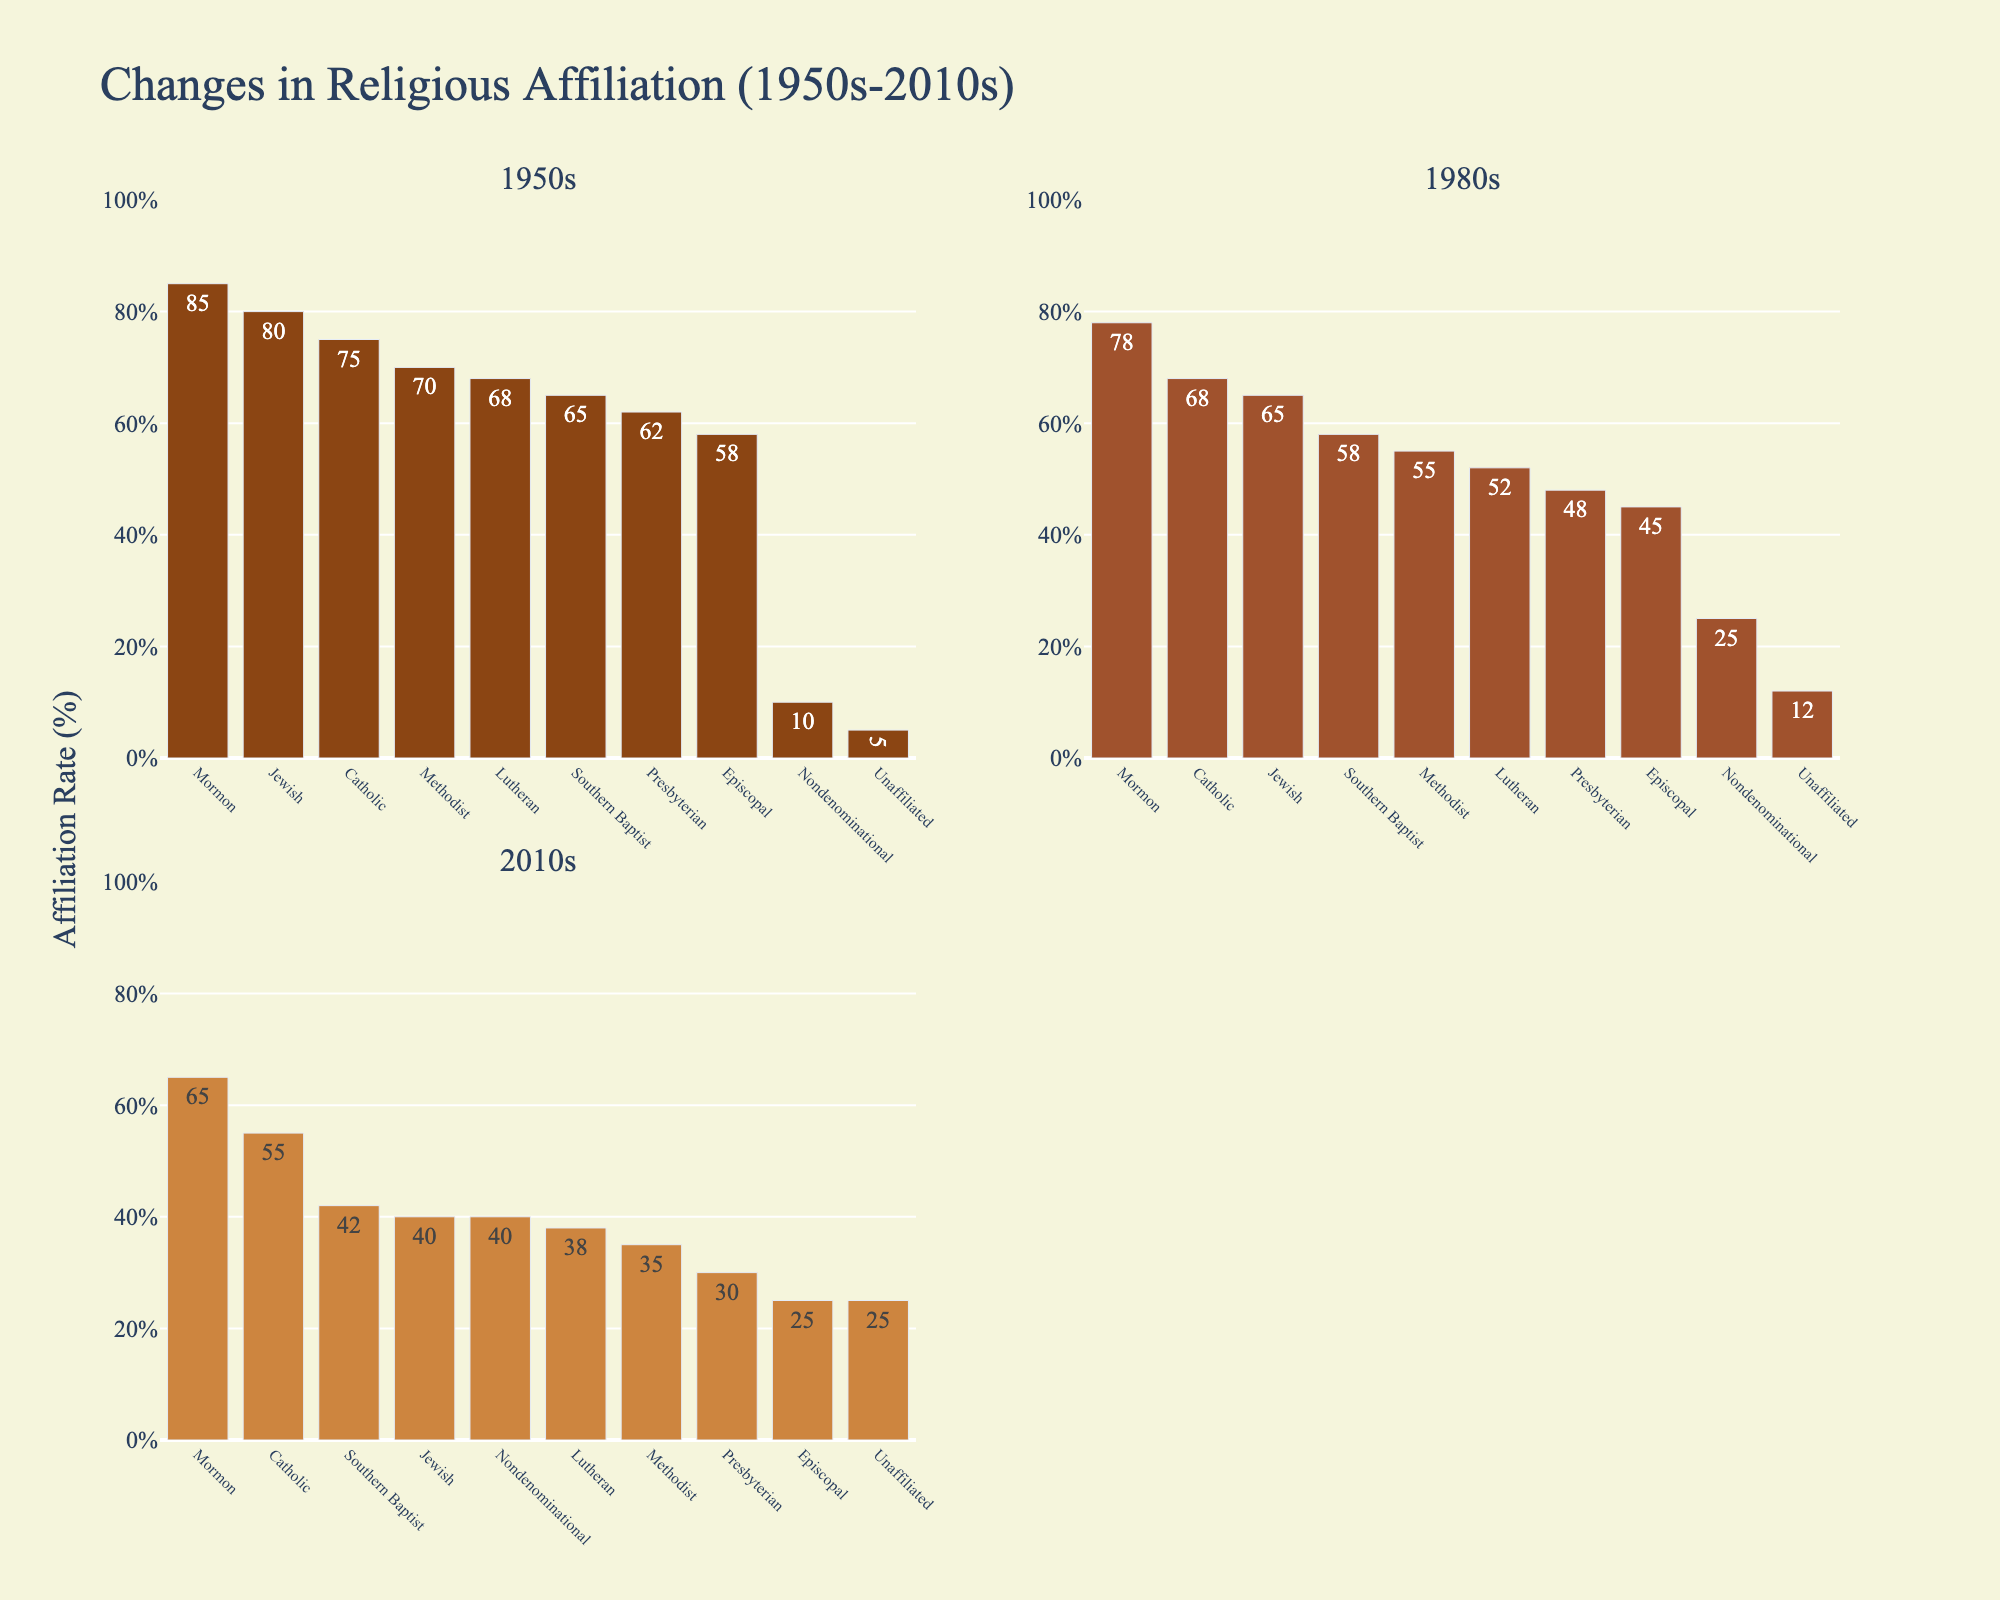what are the most represented denominations in the 1950s? Look for the bar with the highest value in the subplot labeled "1950s". The bars for "Jewish" and "Mormon" are the largest.
Answer: Jewish, Mormon How many denominations had an affiliation rate of at least 50% in the 1950s? Count the number of bars above or equal to the 50% line in the "1950s" subplot.
Answer: 7 What was the affiliation rate for Nondenominational in the 2010s? Look at the bar labeled "Nondenominational" in the "2010s" subplot.
Answer: 40% What trend do you observe in the affiliation rates of Southern Baptist from 1950s to 2010s? Observe the height of the bars for "Southern Baptist" across the three subplots. There is a downward trend.
Answer: Downward Which denomination showed the largest decrease in affiliation rate from the 1950s to the 2010s? Calculate the percentage decrease for each denomination and identify the largest one. "Episcopal" drops from 58% to 25%, which is a decrease of 33%.
Answer: Episcopal In the 1980s, did more denominations have an affiliation rate above 50% than below it? Count the number of bars above and below the 50% line in the "1980s" subplot.
Answer: No What is the combined affiliation rate for Unaifillated and Nondenominational in the 2010s? Add the affiliation rates for "Unaffiliated" (25%) and "Nondenominational" (40%) in the "2010s" subplot.
Answer: 65% Did any denomination experience an increase in affiliation rates from the 1950s to the 2010s? Compare bars' heights across the three subplots for each denomination. Only the "Nondenominational" saw an increase.
Answer: Nondenominational Which decade shows the highest affiliation rate for the Catholic denomination? Compare the heights of the "Catholic" bars in each of the three subplots and identify the highest one.
Answer: 1950s How much did the Presbyterian affiliation rate change from the 1980s to the 2010s? Subtract the Presbyterian rate in the 2010s (30%) from the rate in the 1980s (48%).
Answer: 18% 